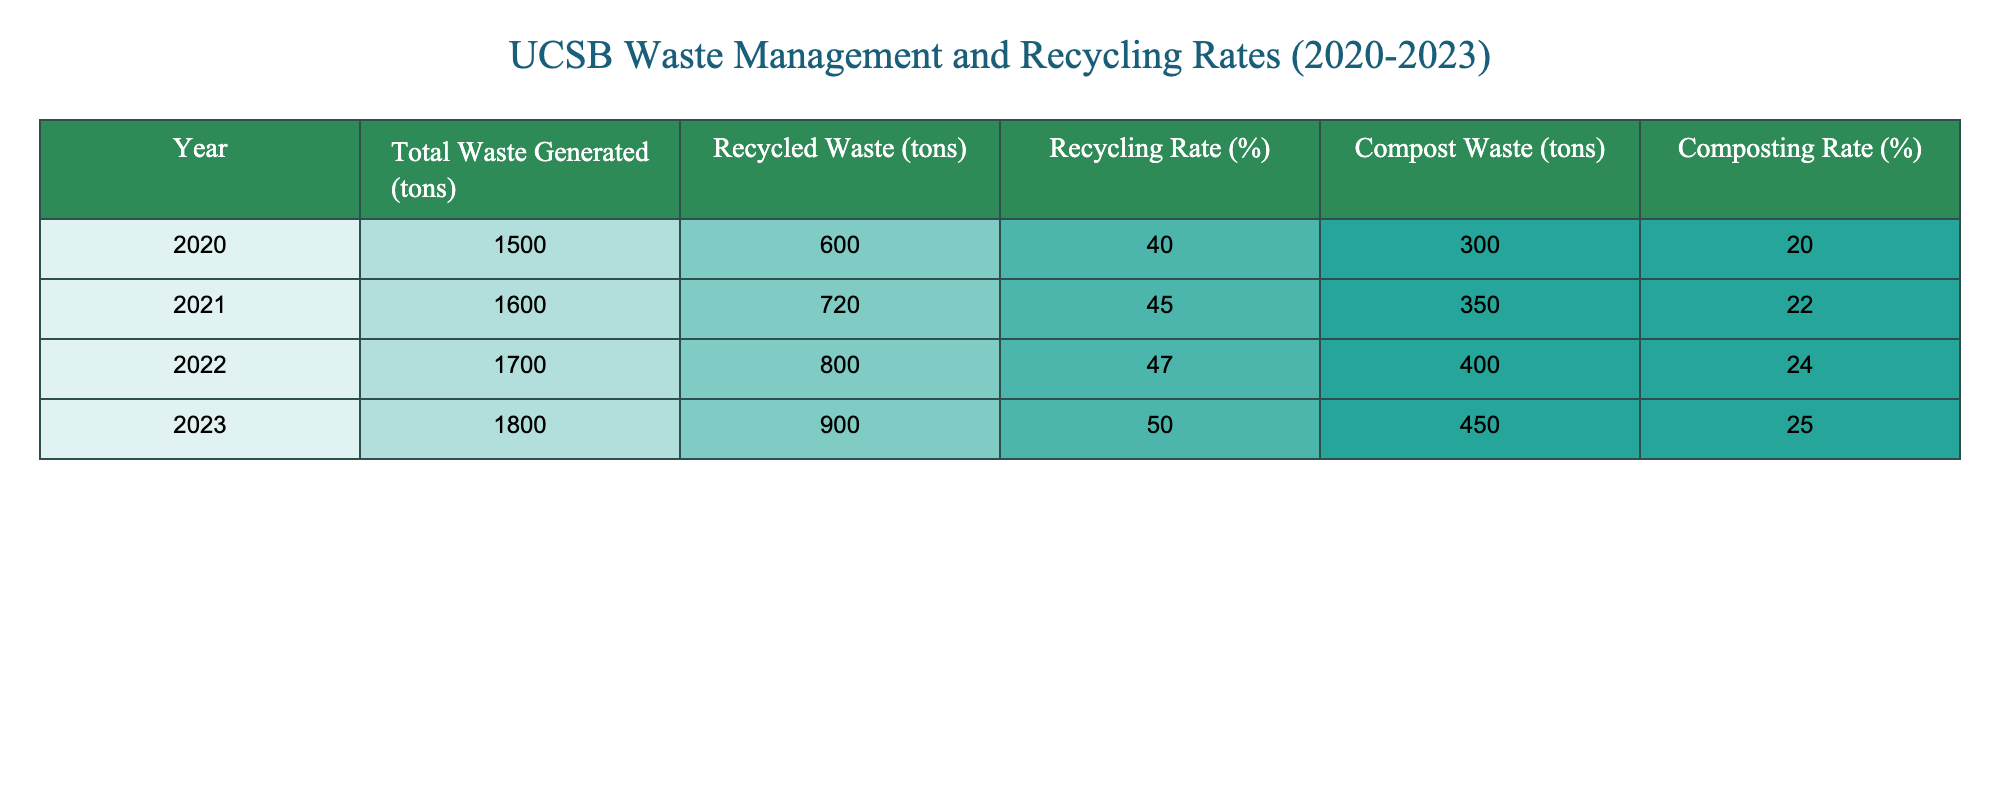What's the total waste generated in 2021? Referring to the table, the value in the "Total Waste Generated (tons)" column for the year 2021 is 1600 tons.
Answer: 1600 tons What was the recycling rate in 2023? By looking at the "Recycling Rate (%)" column for the year 2023, the value is 50%.
Answer: 50% How much compost waste was generated in 2022? Checking the "Compost Waste (tons)" column for the year 2022, it shows 400 tons of compost waste generated.
Answer: 400 tons What is the average recycling rate from 2020 to 2023? The recycling rates for the years are 40%, 45%, 47%, and 50%. To find the average, we sum these rates: 40 + 45 + 47 + 50 = 182, then divide by 4 (the number of years): 182/4 = 45.5%.
Answer: 45.5% Was the total waste generated in 2020 less than that in 2023? Comparing the total waste generated in 2020 (1500 tons) with that in 2023 (1800 tons), 1500 < 1800, so the statement is true.
Answer: Yes Is the composting rate higher than the recycling rate for any year? By examining the composting and recycling rates side by side, in 2020 (20% vs 40%), 2021 (22% vs 45%), 2022 (24% vs 47%), and 2023 (25% vs 50%), the composting rate is never higher than the recycling rate.
Answer: No What is the difference in recycled waste between 2021 and 2023? The recycled waste for 2021 is 720 tons, and for 2023, it is 900 tons. The difference is calculated as 900 - 720 = 180 tons.
Answer: 180 tons What percentage increase in compost waste was observed from 2020 to 2023? The compost waste in 2020 was 300 tons, and in 2023, it was 450 tons. To find the increase, we calculate: (450 - 300) / 300 * 100 = 50%.
Answer: 50% What was the total waste generated over the four years combined? Summing the total waste generated for each year: 1500 + 1600 + 1700 + 1800 = 6600 tons.
Answer: 6600 tons 